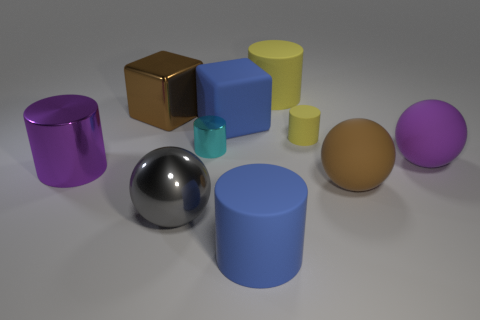How many other objects are there of the same color as the big metal cube?
Provide a short and direct response. 1. What number of things are big rubber cylinders or small yellow matte objects that are on the right side of the large blue cube?
Keep it short and to the point. 3. What color is the cube to the left of the cyan cylinder?
Your answer should be compact. Brown. What is the shape of the large yellow object?
Offer a terse response. Cylinder. There is a large cylinder that is to the right of the large matte thing in front of the brown rubber object; what is its material?
Keep it short and to the point. Rubber. What number of other things are the same material as the blue cylinder?
Your answer should be compact. 5. There is a brown block that is the same size as the blue matte cube; what is it made of?
Make the answer very short. Metal. Are there more gray metallic balls left of the large brown metallic object than small cyan shiny things that are in front of the purple sphere?
Your response must be concise. No. Is there a brown object of the same shape as the big purple shiny thing?
Your answer should be very brief. No. There is a gray metal object that is the same size as the rubber block; what shape is it?
Provide a succinct answer. Sphere. 